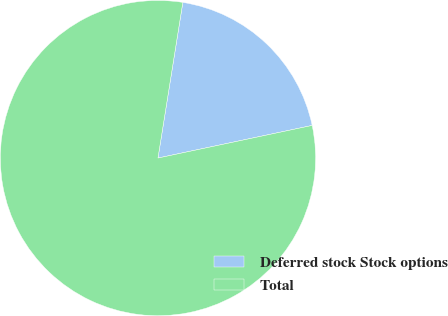Convert chart. <chart><loc_0><loc_0><loc_500><loc_500><pie_chart><fcel>Deferred stock Stock options<fcel>Total<nl><fcel>19.16%<fcel>80.84%<nl></chart> 